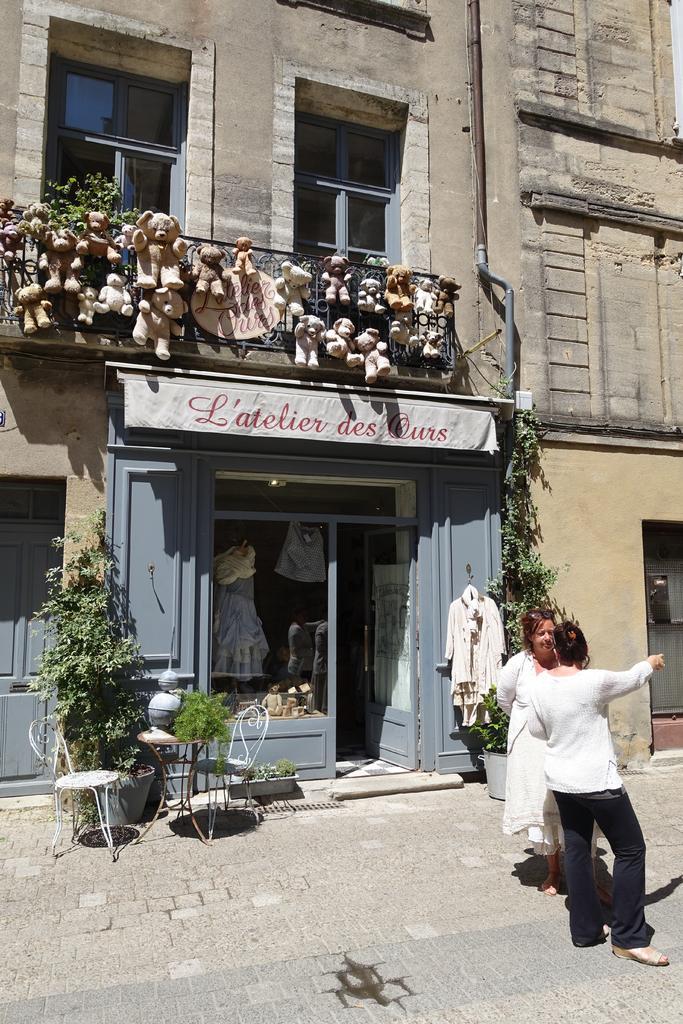Can you describe this image briefly? In this picture we can see two women are talking each to other, in the background we can see couple of plants, chairs, toys and a building. 